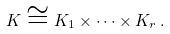<formula> <loc_0><loc_0><loc_500><loc_500>K \cong K _ { 1 } \times \cdots \times K _ { r } \, .</formula> 